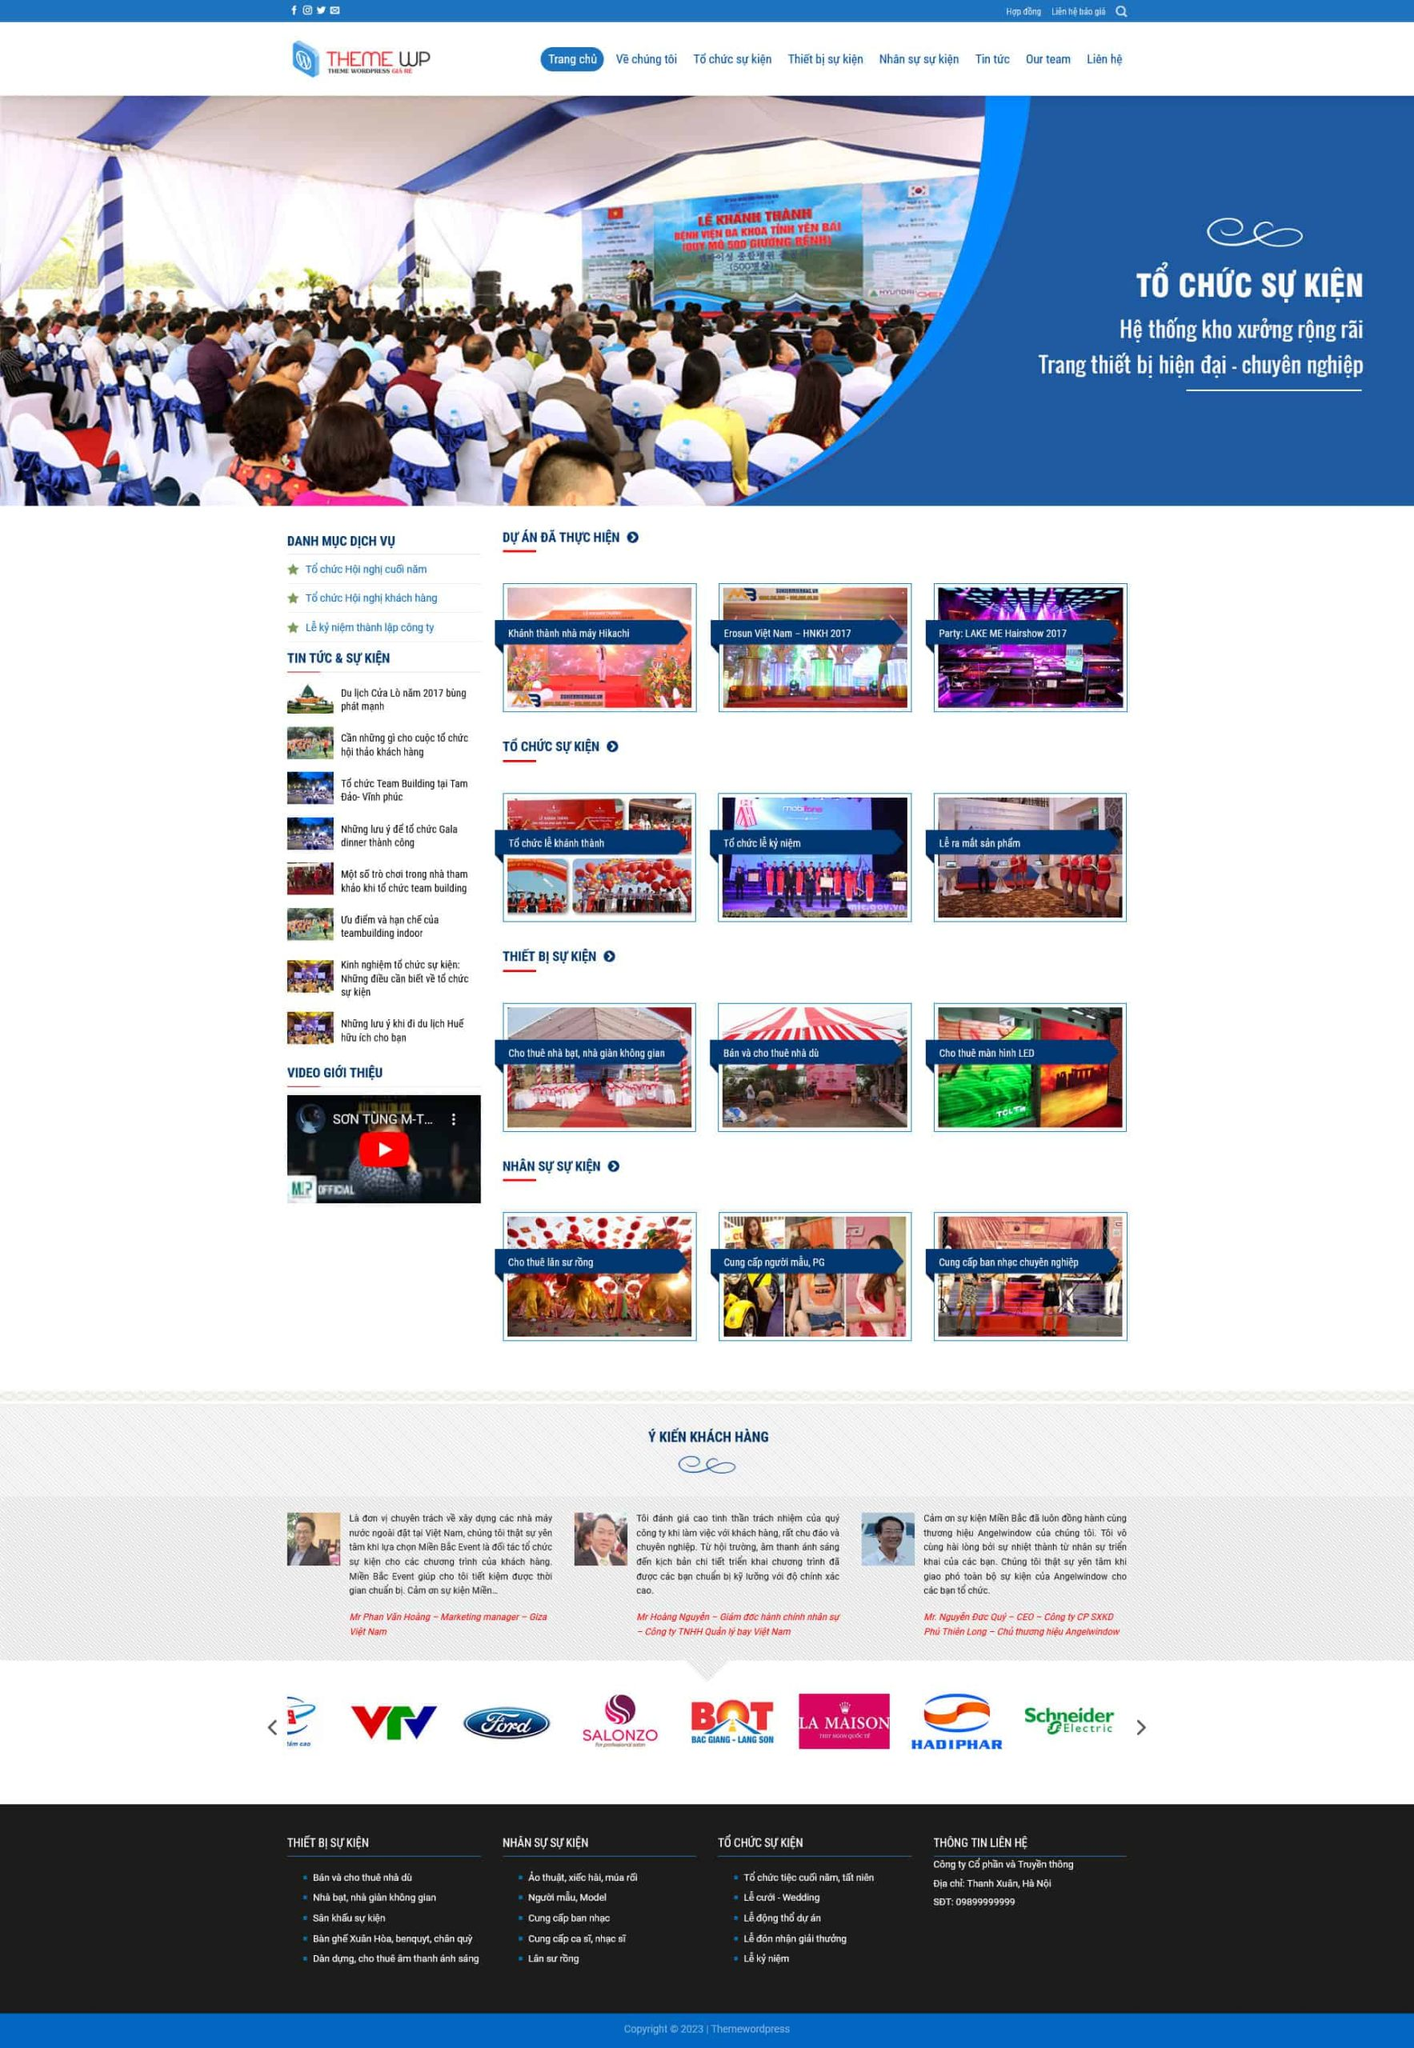Liệt kê 5 ngành nghề, lĩnh vực phù hợp với website này, phân cách các màu sắc bằng dấu phẩy. Chỉ trả về kết quả, phân cách bằng dấy phẩy
 Tổ chức sự kiện, Thiết bị sự kiện, Cho thuê sân khấu, Cho thuê âm thanh ánh sáng, Cung cấp nhân sự sự kiện 